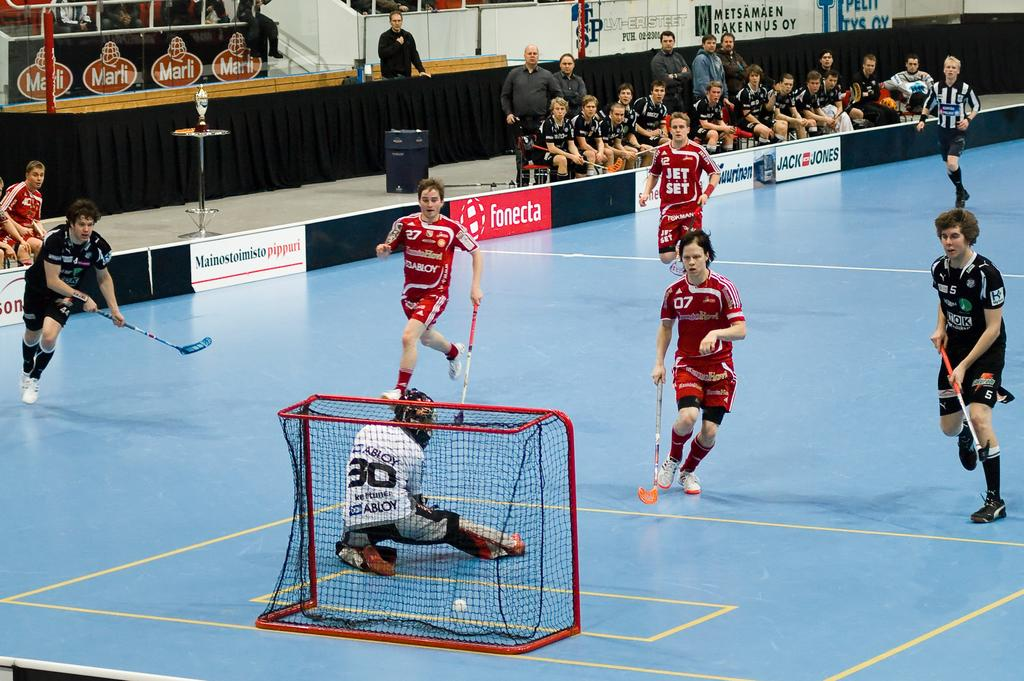<image>
Write a terse but informative summary of the picture. A group of indoor field hockey players look on as number 30 misses defending the goal. 